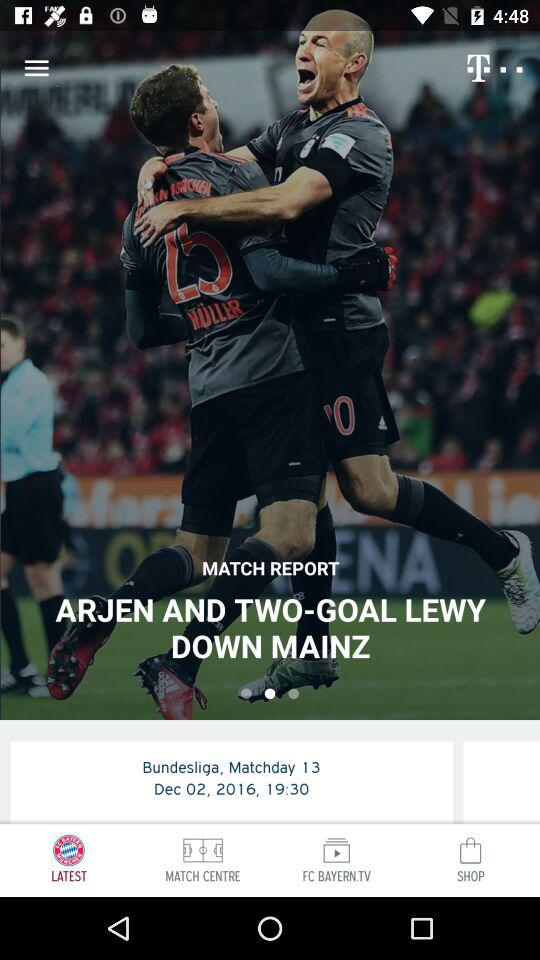What is the date of the match?
Answer the question using a single word or phrase. Dec 02, 2016 